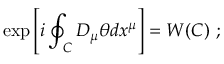<formula> <loc_0><loc_0><loc_500><loc_500>\exp \left [ i \oint _ { C } D _ { \mu } \theta d x ^ { \mu } \right ] = W ( C ) ;</formula> 